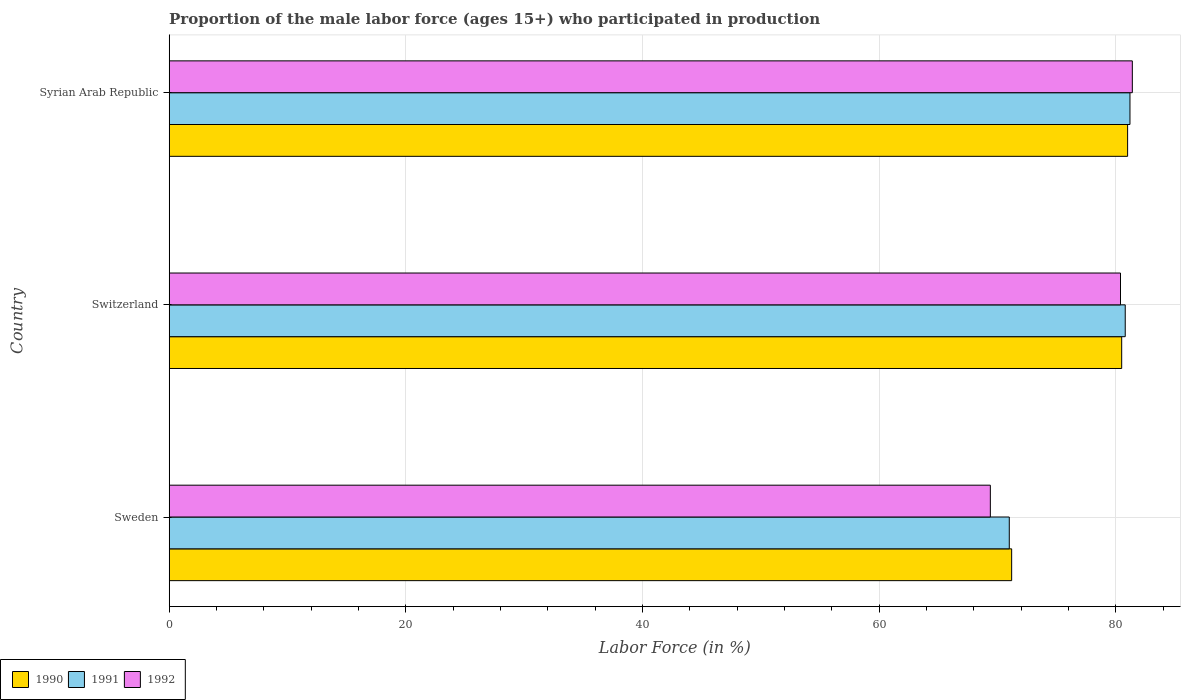Are the number of bars on each tick of the Y-axis equal?
Keep it short and to the point. Yes. What is the label of the 1st group of bars from the top?
Your answer should be compact. Syrian Arab Republic. What is the proportion of the male labor force who participated in production in 1991 in Sweden?
Keep it short and to the point. 71. Across all countries, what is the maximum proportion of the male labor force who participated in production in 1992?
Your response must be concise. 81.4. Across all countries, what is the minimum proportion of the male labor force who participated in production in 1990?
Offer a terse response. 71.2. In which country was the proportion of the male labor force who participated in production in 1992 maximum?
Provide a succinct answer. Syrian Arab Republic. What is the total proportion of the male labor force who participated in production in 1992 in the graph?
Offer a terse response. 231.2. What is the difference between the proportion of the male labor force who participated in production in 1991 in Switzerland and that in Syrian Arab Republic?
Your answer should be very brief. -0.4. What is the difference between the proportion of the male labor force who participated in production in 1990 in Switzerland and the proportion of the male labor force who participated in production in 1991 in Syrian Arab Republic?
Provide a short and direct response. -0.7. What is the average proportion of the male labor force who participated in production in 1991 per country?
Ensure brevity in your answer.  77.67. What is the difference between the proportion of the male labor force who participated in production in 1991 and proportion of the male labor force who participated in production in 1990 in Switzerland?
Offer a terse response. 0.3. In how many countries, is the proportion of the male labor force who participated in production in 1992 greater than 68 %?
Make the answer very short. 3. What is the ratio of the proportion of the male labor force who participated in production in 1991 in Switzerland to that in Syrian Arab Republic?
Your answer should be compact. 1. Is the proportion of the male labor force who participated in production in 1990 in Switzerland less than that in Syrian Arab Republic?
Offer a terse response. Yes. What is the difference between the highest and the second highest proportion of the male labor force who participated in production in 1992?
Your response must be concise. 1. What is the difference between the highest and the lowest proportion of the male labor force who participated in production in 1990?
Offer a terse response. 9.8. In how many countries, is the proportion of the male labor force who participated in production in 1990 greater than the average proportion of the male labor force who participated in production in 1990 taken over all countries?
Your response must be concise. 2. Is the sum of the proportion of the male labor force who participated in production in 1990 in Sweden and Switzerland greater than the maximum proportion of the male labor force who participated in production in 1991 across all countries?
Make the answer very short. Yes. What does the 2nd bar from the bottom in Switzerland represents?
Make the answer very short. 1991. Is it the case that in every country, the sum of the proportion of the male labor force who participated in production in 1991 and proportion of the male labor force who participated in production in 1992 is greater than the proportion of the male labor force who participated in production in 1990?
Offer a very short reply. Yes. What is the difference between two consecutive major ticks on the X-axis?
Your response must be concise. 20. Are the values on the major ticks of X-axis written in scientific E-notation?
Your answer should be very brief. No. Does the graph contain grids?
Ensure brevity in your answer.  Yes. Where does the legend appear in the graph?
Give a very brief answer. Bottom left. How many legend labels are there?
Your response must be concise. 3. What is the title of the graph?
Your answer should be compact. Proportion of the male labor force (ages 15+) who participated in production. Does "1973" appear as one of the legend labels in the graph?
Offer a terse response. No. What is the label or title of the X-axis?
Provide a succinct answer. Labor Force (in %). What is the label or title of the Y-axis?
Your answer should be compact. Country. What is the Labor Force (in %) of 1990 in Sweden?
Make the answer very short. 71.2. What is the Labor Force (in %) of 1991 in Sweden?
Provide a short and direct response. 71. What is the Labor Force (in %) of 1992 in Sweden?
Provide a short and direct response. 69.4. What is the Labor Force (in %) of 1990 in Switzerland?
Ensure brevity in your answer.  80.5. What is the Labor Force (in %) of 1991 in Switzerland?
Provide a short and direct response. 80.8. What is the Labor Force (in %) of 1992 in Switzerland?
Keep it short and to the point. 80.4. What is the Labor Force (in %) of 1991 in Syrian Arab Republic?
Make the answer very short. 81.2. What is the Labor Force (in %) of 1992 in Syrian Arab Republic?
Your answer should be very brief. 81.4. Across all countries, what is the maximum Labor Force (in %) of 1991?
Keep it short and to the point. 81.2. Across all countries, what is the maximum Labor Force (in %) of 1992?
Your response must be concise. 81.4. Across all countries, what is the minimum Labor Force (in %) of 1990?
Provide a short and direct response. 71.2. Across all countries, what is the minimum Labor Force (in %) of 1992?
Your answer should be compact. 69.4. What is the total Labor Force (in %) in 1990 in the graph?
Your answer should be compact. 232.7. What is the total Labor Force (in %) in 1991 in the graph?
Your response must be concise. 233. What is the total Labor Force (in %) of 1992 in the graph?
Provide a short and direct response. 231.2. What is the difference between the Labor Force (in %) of 1990 in Sweden and that in Switzerland?
Your response must be concise. -9.3. What is the difference between the Labor Force (in %) of 1992 in Sweden and that in Switzerland?
Give a very brief answer. -11. What is the difference between the Labor Force (in %) in 1990 in Sweden and that in Syrian Arab Republic?
Your response must be concise. -9.8. What is the difference between the Labor Force (in %) of 1992 in Sweden and that in Syrian Arab Republic?
Make the answer very short. -12. What is the difference between the Labor Force (in %) in 1990 in Switzerland and that in Syrian Arab Republic?
Provide a succinct answer. -0.5. What is the difference between the Labor Force (in %) of 1991 in Switzerland and that in Syrian Arab Republic?
Offer a terse response. -0.4. What is the difference between the Labor Force (in %) of 1990 in Sweden and the Labor Force (in %) of 1992 in Switzerland?
Ensure brevity in your answer.  -9.2. What is the difference between the Labor Force (in %) in 1990 in Sweden and the Labor Force (in %) in 1991 in Syrian Arab Republic?
Offer a terse response. -10. What is the difference between the Labor Force (in %) in 1990 in Switzerland and the Labor Force (in %) in 1991 in Syrian Arab Republic?
Provide a short and direct response. -0.7. What is the difference between the Labor Force (in %) in 1990 in Switzerland and the Labor Force (in %) in 1992 in Syrian Arab Republic?
Your response must be concise. -0.9. What is the average Labor Force (in %) of 1990 per country?
Ensure brevity in your answer.  77.57. What is the average Labor Force (in %) in 1991 per country?
Offer a terse response. 77.67. What is the average Labor Force (in %) of 1992 per country?
Provide a short and direct response. 77.07. What is the difference between the Labor Force (in %) in 1990 and Labor Force (in %) in 1992 in Sweden?
Your response must be concise. 1.8. What is the difference between the Labor Force (in %) in 1991 and Labor Force (in %) in 1992 in Switzerland?
Give a very brief answer. 0.4. What is the ratio of the Labor Force (in %) in 1990 in Sweden to that in Switzerland?
Your response must be concise. 0.88. What is the ratio of the Labor Force (in %) of 1991 in Sweden to that in Switzerland?
Your answer should be very brief. 0.88. What is the ratio of the Labor Force (in %) in 1992 in Sweden to that in Switzerland?
Keep it short and to the point. 0.86. What is the ratio of the Labor Force (in %) of 1990 in Sweden to that in Syrian Arab Republic?
Your answer should be compact. 0.88. What is the ratio of the Labor Force (in %) of 1991 in Sweden to that in Syrian Arab Republic?
Provide a short and direct response. 0.87. What is the ratio of the Labor Force (in %) in 1992 in Sweden to that in Syrian Arab Republic?
Your answer should be very brief. 0.85. What is the ratio of the Labor Force (in %) of 1990 in Switzerland to that in Syrian Arab Republic?
Keep it short and to the point. 0.99. What is the ratio of the Labor Force (in %) in 1991 in Switzerland to that in Syrian Arab Republic?
Give a very brief answer. 1. What is the ratio of the Labor Force (in %) of 1992 in Switzerland to that in Syrian Arab Republic?
Keep it short and to the point. 0.99. What is the difference between the highest and the second highest Labor Force (in %) of 1990?
Provide a succinct answer. 0.5. What is the difference between the highest and the second highest Labor Force (in %) of 1991?
Your response must be concise. 0.4. What is the difference between the highest and the second highest Labor Force (in %) in 1992?
Your answer should be very brief. 1. What is the difference between the highest and the lowest Labor Force (in %) of 1990?
Your answer should be very brief. 9.8. 